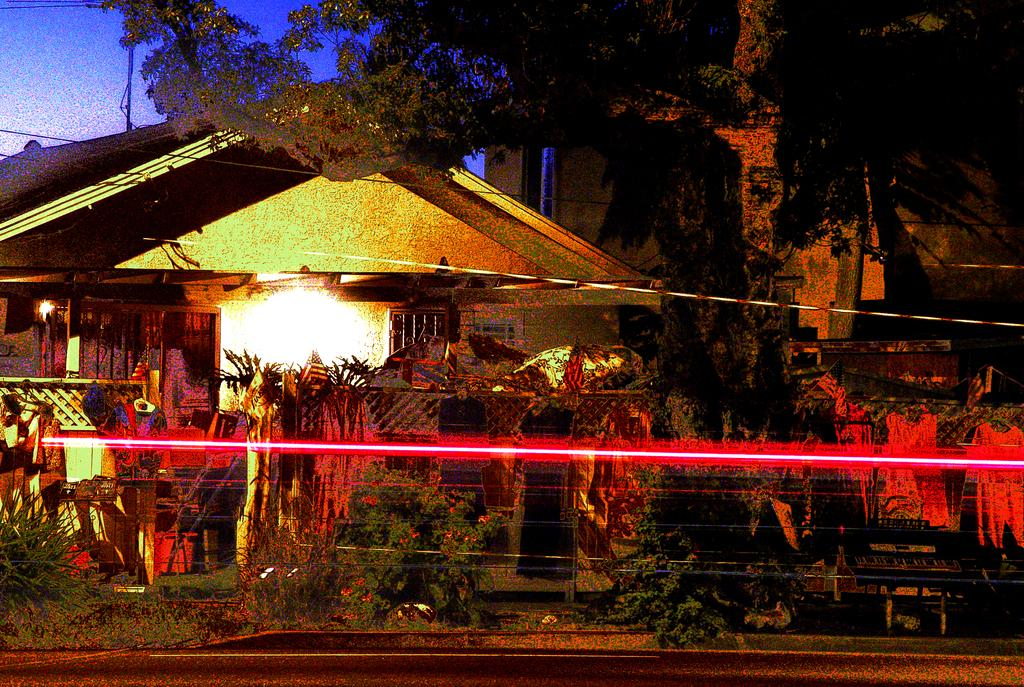What type of structures can be seen in the image? There are houses in the image. What type of vegetation is present in the image? There are trees, plants, and flower pots in the image. What is the purpose of the wall in the image? The wall serves as a boundary or divider in the image. What type of illumination is present in the image? There are lights in the image. What type of objects can be seen in the image? There are some objects in the image, but their specific nature is not mentioned. What is the surface at the bottom of the image? There is a road at the bottom of the image. What type of infrastructure is present in the image? There are wires and a pole in the image. What is visible at the top of the image? The sky is visible at the top of the image. What type of education can be seen in the image? There is no reference to education in the image. What type of key is used to unlock the door in the image? There is no door or key present in the image. What type of joke is being told by the person in the image? There is no person or joke present in the image. 